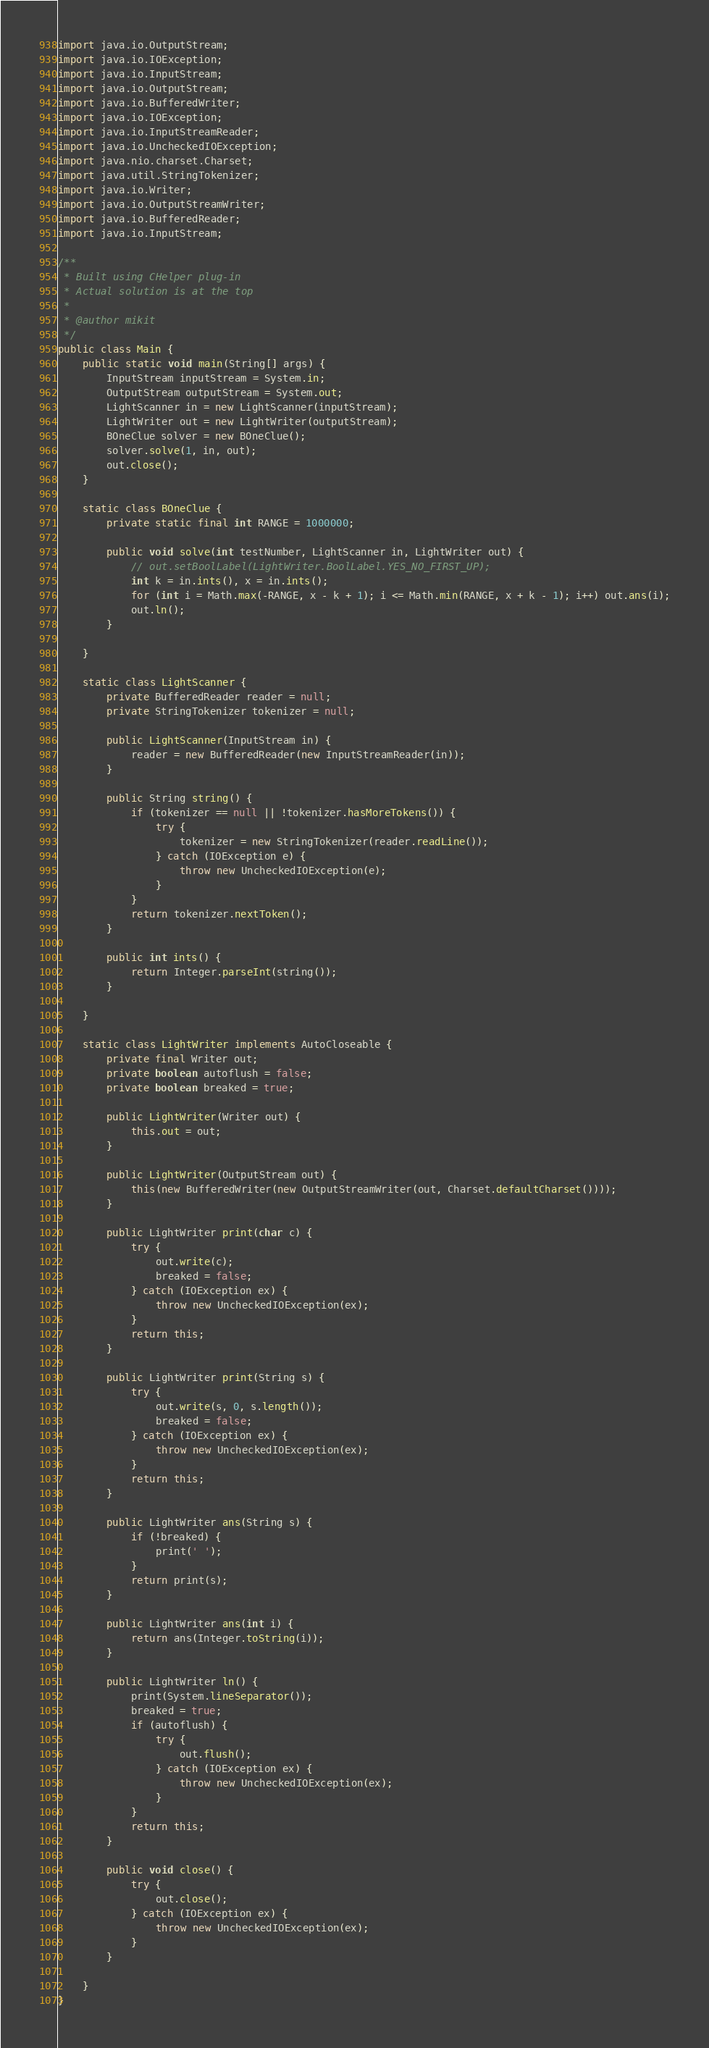<code> <loc_0><loc_0><loc_500><loc_500><_Java_>import java.io.OutputStream;
import java.io.IOException;
import java.io.InputStream;
import java.io.OutputStream;
import java.io.BufferedWriter;
import java.io.IOException;
import java.io.InputStreamReader;
import java.io.UncheckedIOException;
import java.nio.charset.Charset;
import java.util.StringTokenizer;
import java.io.Writer;
import java.io.OutputStreamWriter;
import java.io.BufferedReader;
import java.io.InputStream;

/**
 * Built using CHelper plug-in
 * Actual solution is at the top
 *
 * @author mikit
 */
public class Main {
    public static void main(String[] args) {
        InputStream inputStream = System.in;
        OutputStream outputStream = System.out;
        LightScanner in = new LightScanner(inputStream);
        LightWriter out = new LightWriter(outputStream);
        BOneClue solver = new BOneClue();
        solver.solve(1, in, out);
        out.close();
    }

    static class BOneClue {
        private static final int RANGE = 1000000;

        public void solve(int testNumber, LightScanner in, LightWriter out) {
            // out.setBoolLabel(LightWriter.BoolLabel.YES_NO_FIRST_UP);
            int k = in.ints(), x = in.ints();
            for (int i = Math.max(-RANGE, x - k + 1); i <= Math.min(RANGE, x + k - 1); i++) out.ans(i);
            out.ln();
        }

    }

    static class LightScanner {
        private BufferedReader reader = null;
        private StringTokenizer tokenizer = null;

        public LightScanner(InputStream in) {
            reader = new BufferedReader(new InputStreamReader(in));
        }

        public String string() {
            if (tokenizer == null || !tokenizer.hasMoreTokens()) {
                try {
                    tokenizer = new StringTokenizer(reader.readLine());
                } catch (IOException e) {
                    throw new UncheckedIOException(e);
                }
            }
            return tokenizer.nextToken();
        }

        public int ints() {
            return Integer.parseInt(string());
        }

    }

    static class LightWriter implements AutoCloseable {
        private final Writer out;
        private boolean autoflush = false;
        private boolean breaked = true;

        public LightWriter(Writer out) {
            this.out = out;
        }

        public LightWriter(OutputStream out) {
            this(new BufferedWriter(new OutputStreamWriter(out, Charset.defaultCharset())));
        }

        public LightWriter print(char c) {
            try {
                out.write(c);
                breaked = false;
            } catch (IOException ex) {
                throw new UncheckedIOException(ex);
            }
            return this;
        }

        public LightWriter print(String s) {
            try {
                out.write(s, 0, s.length());
                breaked = false;
            } catch (IOException ex) {
                throw new UncheckedIOException(ex);
            }
            return this;
        }

        public LightWriter ans(String s) {
            if (!breaked) {
                print(' ');
            }
            return print(s);
        }

        public LightWriter ans(int i) {
            return ans(Integer.toString(i));
        }

        public LightWriter ln() {
            print(System.lineSeparator());
            breaked = true;
            if (autoflush) {
                try {
                    out.flush();
                } catch (IOException ex) {
                    throw new UncheckedIOException(ex);
                }
            }
            return this;
        }

        public void close() {
            try {
                out.close();
            } catch (IOException ex) {
                throw new UncheckedIOException(ex);
            }
        }

    }
}

</code> 